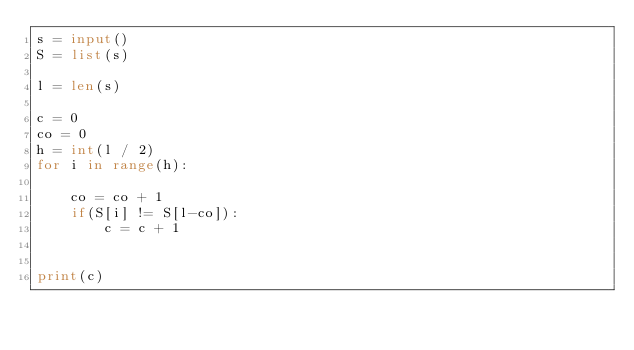<code> <loc_0><loc_0><loc_500><loc_500><_Python_>s = input()
S = list(s)

l = len(s)

c = 0
co = 0
h = int(l / 2)
for i in range(h):

    co = co + 1
    if(S[i] != S[l-co]):
        c = c + 1
    

print(c)</code> 